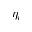Convert formula to latex. <formula><loc_0><loc_0><loc_500><loc_500>\eta _ { i }</formula> 